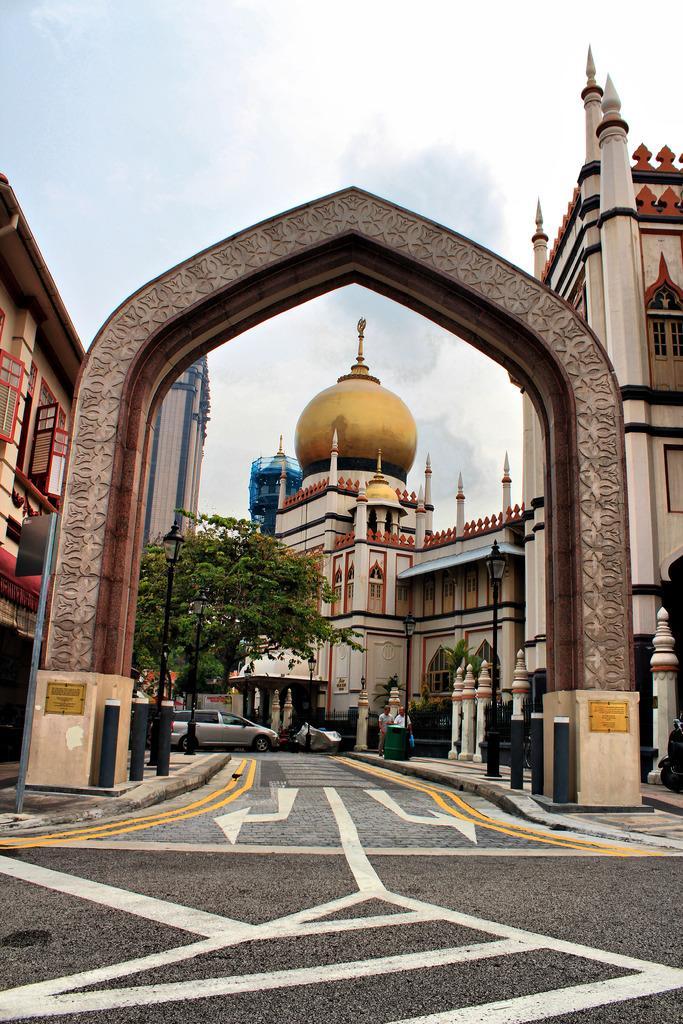Please provide a concise description of this image. In this image I can see main entrance gate and I can see a mosque , in front of the mosque I can see trees, vehicle and persons walking on the divider and I can see a road , in the fire ground at the top I can see the sky and both sides I can see buildings 